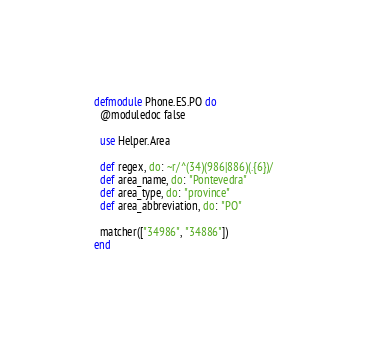Convert code to text. <code><loc_0><loc_0><loc_500><loc_500><_Elixir_>defmodule Phone.ES.PO do
  @moduledoc false

  use Helper.Area

  def regex, do: ~r/^(34)(986|886)(.{6})/
  def area_name, do: "Pontevedra"
  def area_type, do: "province"
  def area_abbreviation, do: "PO"

  matcher(["34986", "34886"])
end
</code> 